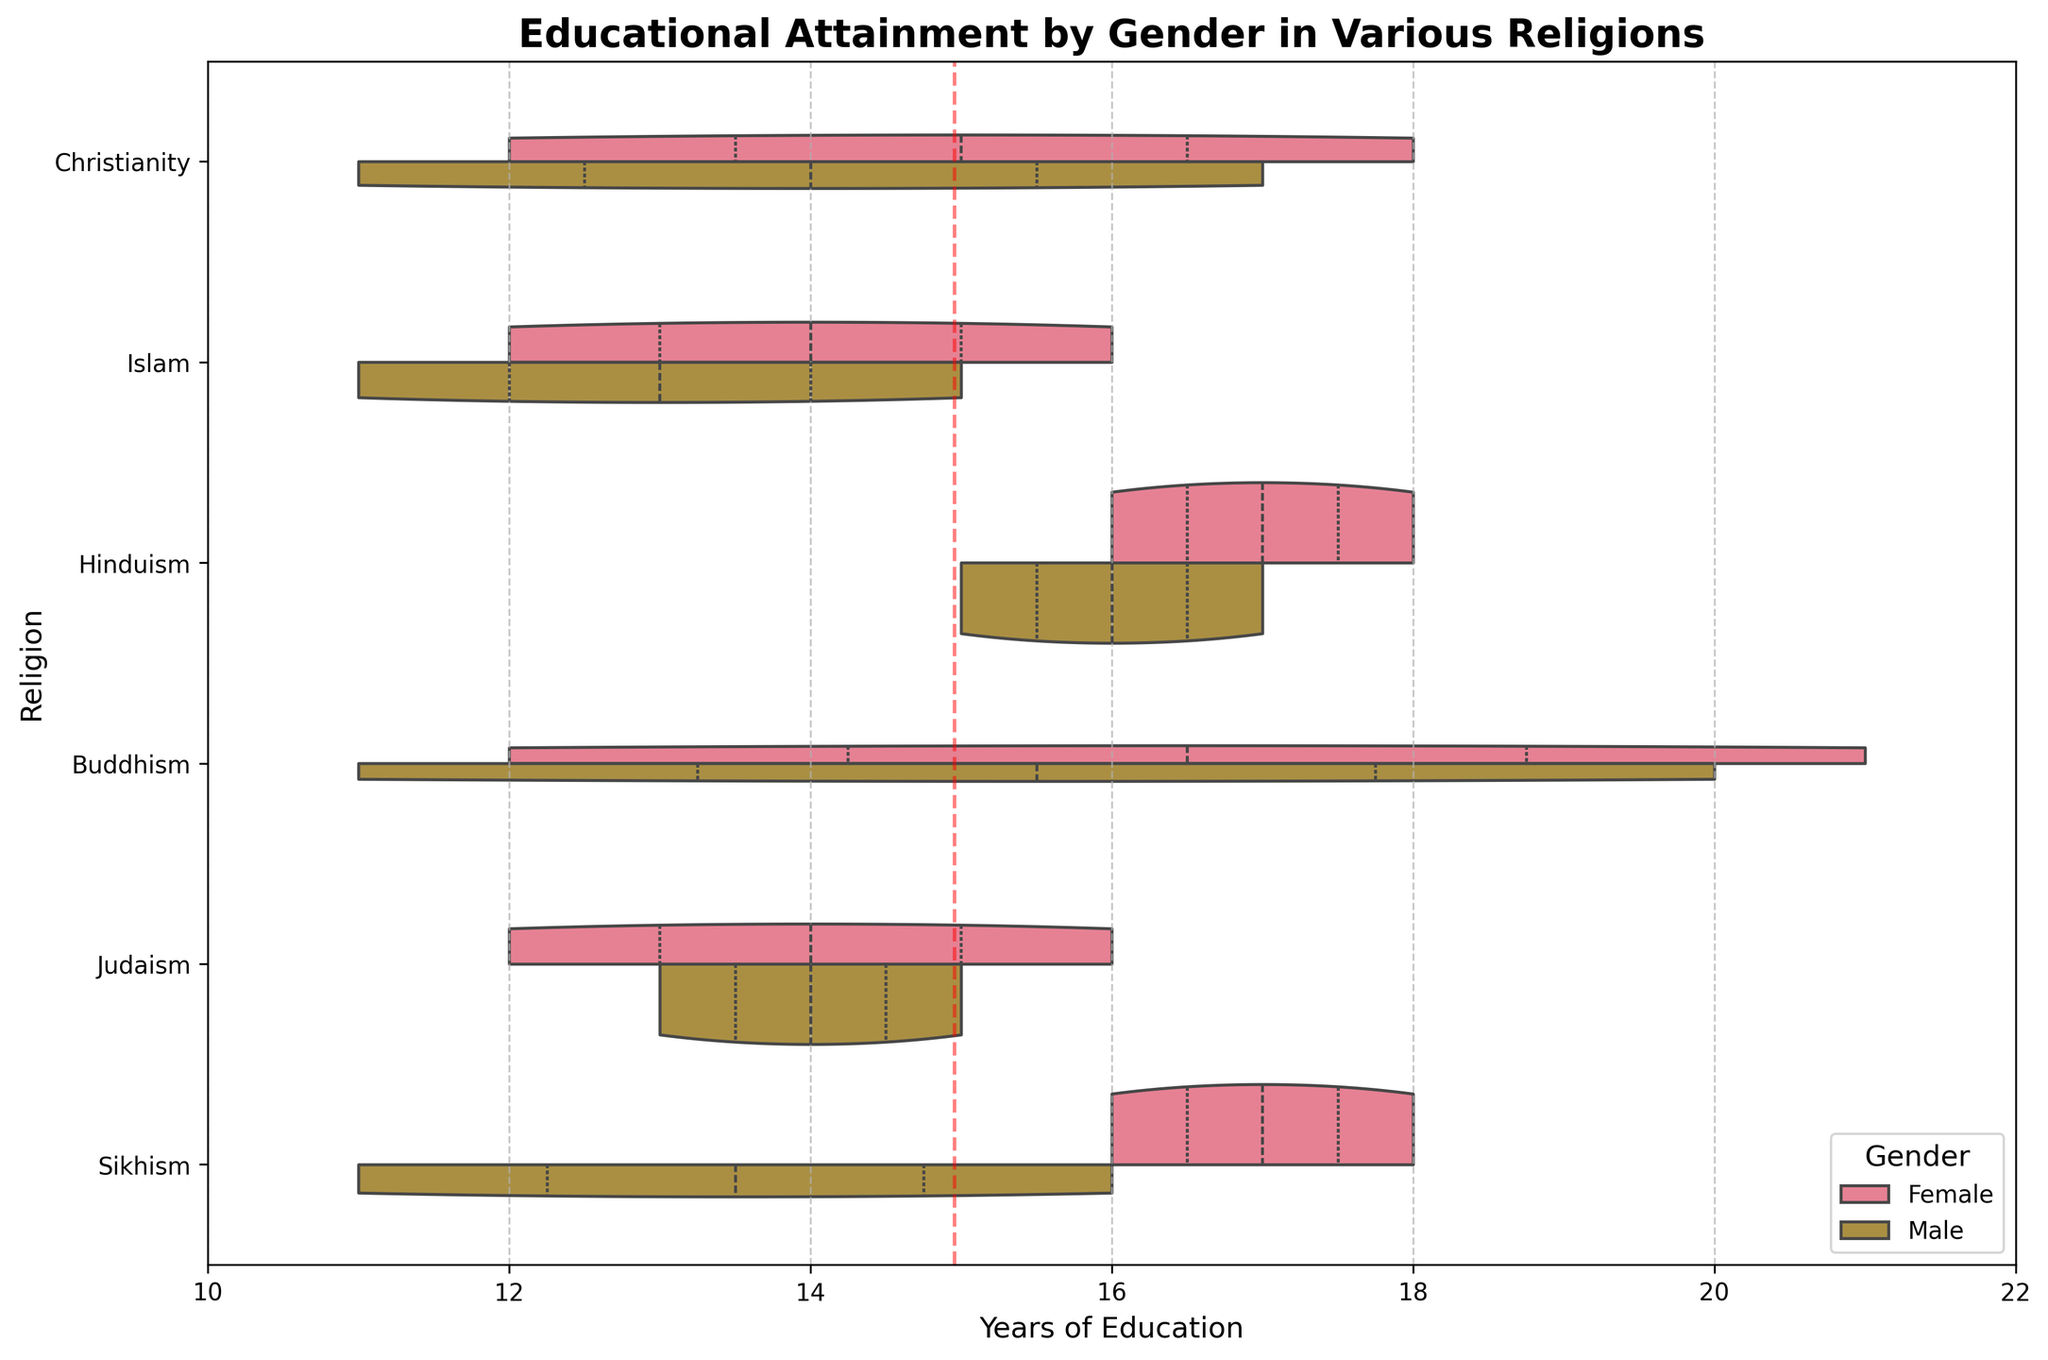What is the title of the figure? The title is usually placed at the top of the figure and gives a brief description of what the figure is about. Here it reads "Educational Attainment by Gender in Various Religions".
Answer: Educational Attainment by Gender in Various Religions What does the X-axis represent in the figure? The X-axis, usually labeled at the bottom of the figure, represents the "Years of Education".
Answer: Years of Education How many religions are compared in the chart? By looking at the Y-axis, we see unique labels for different religions. Here, the unique religions are Christianity, Islam, Hinduism, Buddhism, Judaism, and Sikhism. Counting them gives six religions.
Answer: Six Which gender typically has a higher educational attainment in Buddhism? The different hues split by gender in the violin plot for Buddhism indicate the value. For Buddhism, the female violin plot shape shows a higher range of education levels than the male.
Answer: Female What is the mean years of education across all data points, indicated by the vertical line? The red dashed vertical line represents the overall mean of the years of education. This line crosses the X-axis at 15.5 years.
Answer: 15.5 years Which religion shows the highest observed years of education, and for which gender? To find this, look at the farthest right point in the horizontal direction. Buddhism for the female gender shows the highest observed value with a PhD level, represented as 21 years of education.
Answer: Buddhism, Female Is there a significant overlap in the educational attainment between genders in Sikhism? Observing the violin plots for Sikhism, the shapes for male and female show a substantial overlapping region, indicating similar ranges in educational attainment.
Answer: Yes Which gender has a greater range of educational attainment in Judaism? Evaluate the violin plot shape and range. In Judaism, the female has a broader range from high school to bachelor's degree compared to the male, which shows a slightly narrower range within high school and bachelor's degree levels.
Answer: Female Between Christianity and Islam, which religion has higher educational attainment for males? Comparing the male violin plots for both religions, the maximum attainment for males in Christianity (Master's Degree/17 years) is similar to that in Islam (Bachelor's Degree/15 years). But Christianity has more individuals closer to Master's Degree.
Answer: Christianity 